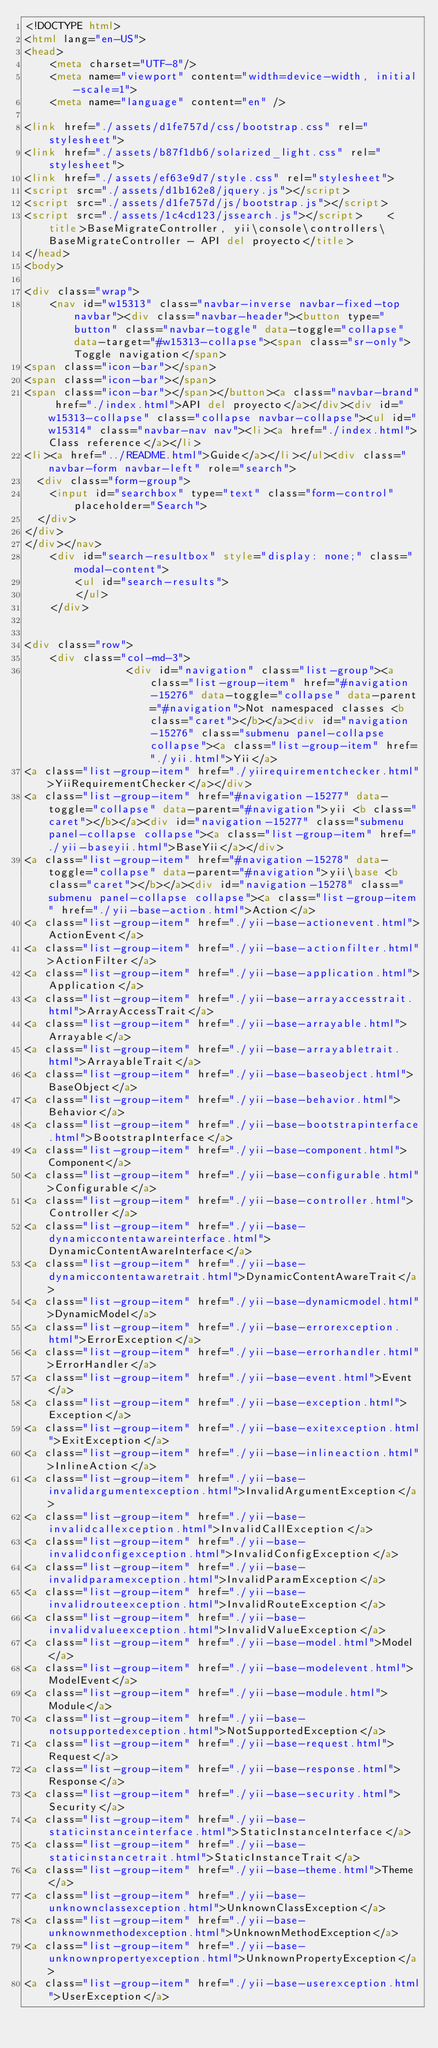Convert code to text. <code><loc_0><loc_0><loc_500><loc_500><_HTML_><!DOCTYPE html>
<html lang="en-US">
<head>
    <meta charset="UTF-8"/>
    <meta name="viewport" content="width=device-width, initial-scale=1">
    <meta name="language" content="en" />
        
<link href="./assets/d1fe757d/css/bootstrap.css" rel="stylesheet">
<link href="./assets/b87f1db6/solarized_light.css" rel="stylesheet">
<link href="./assets/ef63e9d7/style.css" rel="stylesheet">
<script src="./assets/d1b162e8/jquery.js"></script>
<script src="./assets/d1fe757d/js/bootstrap.js"></script>
<script src="./assets/1c4cd123/jssearch.js"></script>    <title>BaseMigrateController, yii\console\controllers\BaseMigrateController - API del proyecto</title>
</head>
<body>

<div class="wrap">
    <nav id="w15313" class="navbar-inverse navbar-fixed-top navbar"><div class="navbar-header"><button type="button" class="navbar-toggle" data-toggle="collapse" data-target="#w15313-collapse"><span class="sr-only">Toggle navigation</span>
<span class="icon-bar"></span>
<span class="icon-bar"></span>
<span class="icon-bar"></span></button><a class="navbar-brand" href="./index.html">API del proyecto</a></div><div id="w15313-collapse" class="collapse navbar-collapse"><ul id="w15314" class="navbar-nav nav"><li><a href="./index.html">Class reference</a></li>
<li><a href="../README.html">Guide</a></li></ul><div class="navbar-form navbar-left" role="search">
  <div class="form-group">
    <input id="searchbox" type="text" class="form-control" placeholder="Search">
  </div>
</div>
</div></nav>
    <div id="search-resultbox" style="display: none;" class="modal-content">
        <ul id="search-results">
        </ul>
    </div>

    
<div class="row">
    <div class="col-md-3">
                <div id="navigation" class="list-group"><a class="list-group-item" href="#navigation-15276" data-toggle="collapse" data-parent="#navigation">Not namespaced classes <b class="caret"></b></a><div id="navigation-15276" class="submenu panel-collapse collapse"><a class="list-group-item" href="./yii.html">Yii</a>
<a class="list-group-item" href="./yiirequirementchecker.html">YiiRequirementChecker</a></div>
<a class="list-group-item" href="#navigation-15277" data-toggle="collapse" data-parent="#navigation">yii <b class="caret"></b></a><div id="navigation-15277" class="submenu panel-collapse collapse"><a class="list-group-item" href="./yii-baseyii.html">BaseYii</a></div>
<a class="list-group-item" href="#navigation-15278" data-toggle="collapse" data-parent="#navigation">yii\base <b class="caret"></b></a><div id="navigation-15278" class="submenu panel-collapse collapse"><a class="list-group-item" href="./yii-base-action.html">Action</a>
<a class="list-group-item" href="./yii-base-actionevent.html">ActionEvent</a>
<a class="list-group-item" href="./yii-base-actionfilter.html">ActionFilter</a>
<a class="list-group-item" href="./yii-base-application.html">Application</a>
<a class="list-group-item" href="./yii-base-arrayaccesstrait.html">ArrayAccessTrait</a>
<a class="list-group-item" href="./yii-base-arrayable.html">Arrayable</a>
<a class="list-group-item" href="./yii-base-arrayabletrait.html">ArrayableTrait</a>
<a class="list-group-item" href="./yii-base-baseobject.html">BaseObject</a>
<a class="list-group-item" href="./yii-base-behavior.html">Behavior</a>
<a class="list-group-item" href="./yii-base-bootstrapinterface.html">BootstrapInterface</a>
<a class="list-group-item" href="./yii-base-component.html">Component</a>
<a class="list-group-item" href="./yii-base-configurable.html">Configurable</a>
<a class="list-group-item" href="./yii-base-controller.html">Controller</a>
<a class="list-group-item" href="./yii-base-dynamiccontentawareinterface.html">DynamicContentAwareInterface</a>
<a class="list-group-item" href="./yii-base-dynamiccontentawaretrait.html">DynamicContentAwareTrait</a>
<a class="list-group-item" href="./yii-base-dynamicmodel.html">DynamicModel</a>
<a class="list-group-item" href="./yii-base-errorexception.html">ErrorException</a>
<a class="list-group-item" href="./yii-base-errorhandler.html">ErrorHandler</a>
<a class="list-group-item" href="./yii-base-event.html">Event</a>
<a class="list-group-item" href="./yii-base-exception.html">Exception</a>
<a class="list-group-item" href="./yii-base-exitexception.html">ExitException</a>
<a class="list-group-item" href="./yii-base-inlineaction.html">InlineAction</a>
<a class="list-group-item" href="./yii-base-invalidargumentexception.html">InvalidArgumentException</a>
<a class="list-group-item" href="./yii-base-invalidcallexception.html">InvalidCallException</a>
<a class="list-group-item" href="./yii-base-invalidconfigexception.html">InvalidConfigException</a>
<a class="list-group-item" href="./yii-base-invalidparamexception.html">InvalidParamException</a>
<a class="list-group-item" href="./yii-base-invalidrouteexception.html">InvalidRouteException</a>
<a class="list-group-item" href="./yii-base-invalidvalueexception.html">InvalidValueException</a>
<a class="list-group-item" href="./yii-base-model.html">Model</a>
<a class="list-group-item" href="./yii-base-modelevent.html">ModelEvent</a>
<a class="list-group-item" href="./yii-base-module.html">Module</a>
<a class="list-group-item" href="./yii-base-notsupportedexception.html">NotSupportedException</a>
<a class="list-group-item" href="./yii-base-request.html">Request</a>
<a class="list-group-item" href="./yii-base-response.html">Response</a>
<a class="list-group-item" href="./yii-base-security.html">Security</a>
<a class="list-group-item" href="./yii-base-staticinstanceinterface.html">StaticInstanceInterface</a>
<a class="list-group-item" href="./yii-base-staticinstancetrait.html">StaticInstanceTrait</a>
<a class="list-group-item" href="./yii-base-theme.html">Theme</a>
<a class="list-group-item" href="./yii-base-unknownclassexception.html">UnknownClassException</a>
<a class="list-group-item" href="./yii-base-unknownmethodexception.html">UnknownMethodException</a>
<a class="list-group-item" href="./yii-base-unknownpropertyexception.html">UnknownPropertyException</a>
<a class="list-group-item" href="./yii-base-userexception.html">UserException</a></code> 